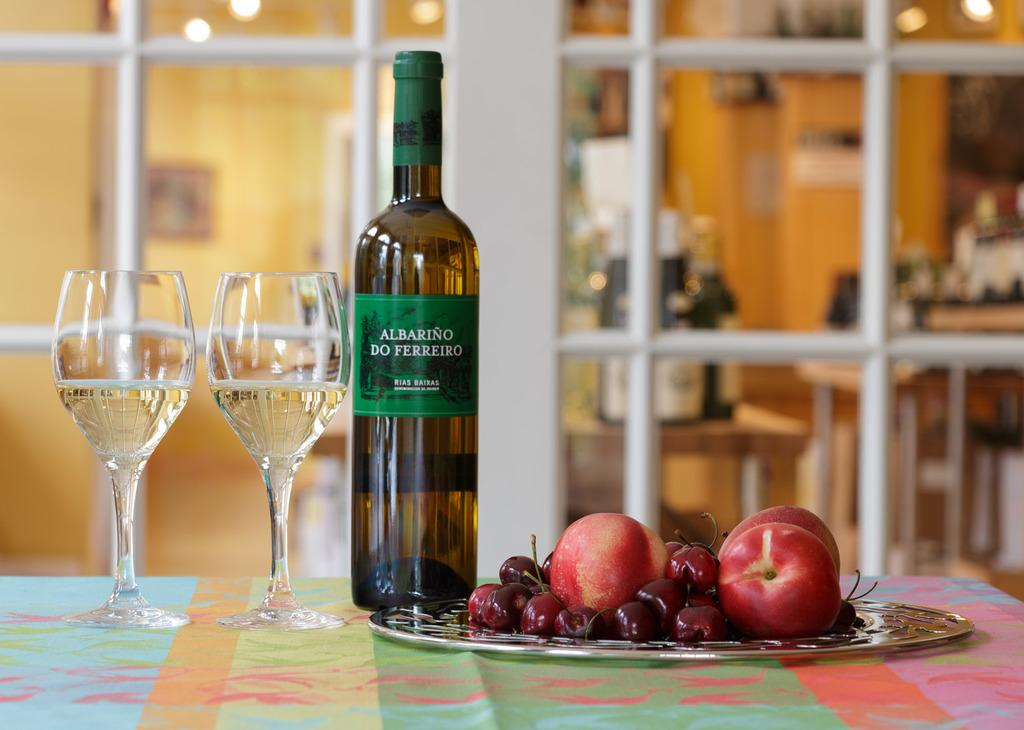What objects are on the table in the image? There are glasses, a bottle, and fruits on the table. Can you describe the contents of the bottle? The contents of the bottle are not visible in the image. What is visible in the background of the image? In the background, there are bottles on a table and a wall. What type of objects are on the table in the background? The objects on the table in the background are bottles. What type of beginner's training is being conducted in the image? There is no indication of any training or activity in the image; it simply shows a table with glasses, a bottle, and fruits, along with a background of bottles on a table and a wall. 